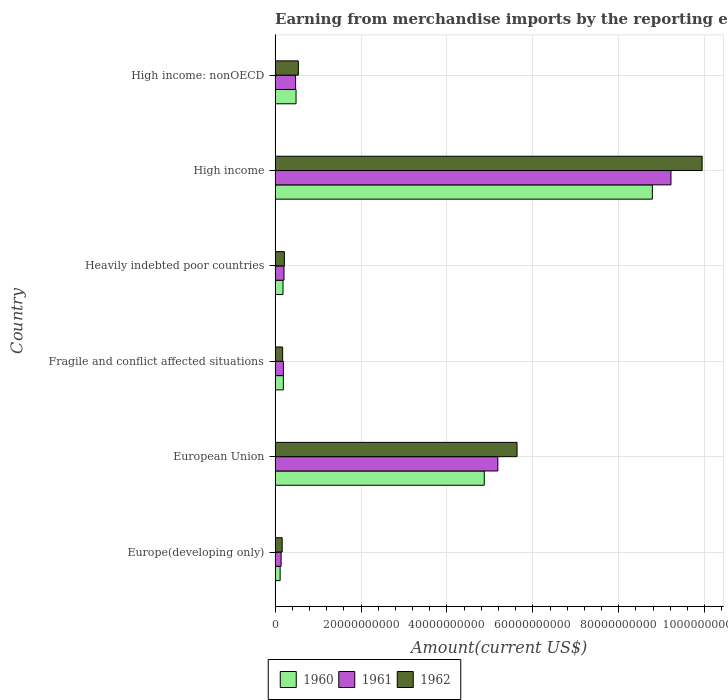How many different coloured bars are there?
Offer a terse response. 3. Are the number of bars on each tick of the Y-axis equal?
Provide a succinct answer. Yes. How many bars are there on the 5th tick from the bottom?
Your response must be concise. 3. What is the amount earned from merchandise imports in 1962 in European Union?
Keep it short and to the point. 5.63e+1. Across all countries, what is the maximum amount earned from merchandise imports in 1962?
Your answer should be compact. 9.94e+1. Across all countries, what is the minimum amount earned from merchandise imports in 1962?
Your answer should be compact. 1.65e+09. In which country was the amount earned from merchandise imports in 1960 maximum?
Provide a short and direct response. High income. In which country was the amount earned from merchandise imports in 1961 minimum?
Provide a short and direct response. Europe(developing only). What is the total amount earned from merchandise imports in 1960 in the graph?
Provide a succinct answer. 1.46e+11. What is the difference between the amount earned from merchandise imports in 1962 in Europe(developing only) and that in Heavily indebted poor countries?
Your response must be concise. -5.09e+08. What is the difference between the amount earned from merchandise imports in 1961 in Heavily indebted poor countries and the amount earned from merchandise imports in 1960 in European Union?
Your response must be concise. -4.66e+1. What is the average amount earned from merchandise imports in 1962 per country?
Ensure brevity in your answer.  2.78e+1. What is the difference between the amount earned from merchandise imports in 1962 and amount earned from merchandise imports in 1961 in High income?
Offer a terse response. 7.26e+09. In how many countries, is the amount earned from merchandise imports in 1962 greater than 76000000000 US$?
Give a very brief answer. 1. What is the ratio of the amount earned from merchandise imports in 1962 in Europe(developing only) to that in High income: nonOECD?
Keep it short and to the point. 0.31. What is the difference between the highest and the second highest amount earned from merchandise imports in 1962?
Ensure brevity in your answer.  4.31e+1. What is the difference between the highest and the lowest amount earned from merchandise imports in 1962?
Your answer should be very brief. 9.78e+1. Is the sum of the amount earned from merchandise imports in 1961 in Europe(developing only) and Fragile and conflict affected situations greater than the maximum amount earned from merchandise imports in 1960 across all countries?
Your answer should be very brief. No. How many countries are there in the graph?
Provide a succinct answer. 6. Are the values on the major ticks of X-axis written in scientific E-notation?
Provide a short and direct response. No. Does the graph contain any zero values?
Your answer should be compact. No. How many legend labels are there?
Keep it short and to the point. 3. What is the title of the graph?
Ensure brevity in your answer.  Earning from merchandise imports by the reporting economy. Does "1993" appear as one of the legend labels in the graph?
Your answer should be compact. No. What is the label or title of the X-axis?
Give a very brief answer. Amount(current US$). What is the label or title of the Y-axis?
Your response must be concise. Country. What is the Amount(current US$) of 1960 in Europe(developing only)?
Your response must be concise. 1.18e+09. What is the Amount(current US$) of 1961 in Europe(developing only)?
Provide a succinct answer. 1.40e+09. What is the Amount(current US$) of 1962 in Europe(developing only)?
Keep it short and to the point. 1.65e+09. What is the Amount(current US$) of 1960 in European Union?
Your response must be concise. 4.87e+1. What is the Amount(current US$) in 1961 in European Union?
Provide a short and direct response. 5.18e+1. What is the Amount(current US$) of 1962 in European Union?
Offer a terse response. 5.63e+1. What is the Amount(current US$) of 1960 in Fragile and conflict affected situations?
Ensure brevity in your answer.  1.92e+09. What is the Amount(current US$) in 1961 in Fragile and conflict affected situations?
Your response must be concise. 1.94e+09. What is the Amount(current US$) in 1962 in Fragile and conflict affected situations?
Your response must be concise. 1.76e+09. What is the Amount(current US$) in 1960 in Heavily indebted poor countries?
Give a very brief answer. 1.84e+09. What is the Amount(current US$) in 1961 in Heavily indebted poor countries?
Keep it short and to the point. 2.07e+09. What is the Amount(current US$) in 1962 in Heavily indebted poor countries?
Your answer should be very brief. 2.16e+09. What is the Amount(current US$) in 1960 in High income?
Provide a short and direct response. 8.78e+1. What is the Amount(current US$) in 1961 in High income?
Your response must be concise. 9.21e+1. What is the Amount(current US$) in 1962 in High income?
Ensure brevity in your answer.  9.94e+1. What is the Amount(current US$) in 1960 in High income: nonOECD?
Provide a short and direct response. 4.88e+09. What is the Amount(current US$) in 1961 in High income: nonOECD?
Give a very brief answer. 4.77e+09. What is the Amount(current US$) of 1962 in High income: nonOECD?
Give a very brief answer. 5.41e+09. Across all countries, what is the maximum Amount(current US$) in 1960?
Your response must be concise. 8.78e+1. Across all countries, what is the maximum Amount(current US$) in 1961?
Make the answer very short. 9.21e+1. Across all countries, what is the maximum Amount(current US$) of 1962?
Your answer should be compact. 9.94e+1. Across all countries, what is the minimum Amount(current US$) in 1960?
Give a very brief answer. 1.18e+09. Across all countries, what is the minimum Amount(current US$) of 1961?
Keep it short and to the point. 1.40e+09. Across all countries, what is the minimum Amount(current US$) in 1962?
Offer a very short reply. 1.65e+09. What is the total Amount(current US$) of 1960 in the graph?
Your answer should be very brief. 1.46e+11. What is the total Amount(current US$) in 1961 in the graph?
Make the answer very short. 1.54e+11. What is the total Amount(current US$) of 1962 in the graph?
Offer a terse response. 1.67e+11. What is the difference between the Amount(current US$) in 1960 in Europe(developing only) and that in European Union?
Provide a short and direct response. -4.75e+1. What is the difference between the Amount(current US$) of 1961 in Europe(developing only) and that in European Union?
Provide a short and direct response. -5.04e+1. What is the difference between the Amount(current US$) of 1962 in Europe(developing only) and that in European Union?
Offer a very short reply. -5.47e+1. What is the difference between the Amount(current US$) of 1960 in Europe(developing only) and that in Fragile and conflict affected situations?
Provide a succinct answer. -7.44e+08. What is the difference between the Amount(current US$) of 1961 in Europe(developing only) and that in Fragile and conflict affected situations?
Your response must be concise. -5.35e+08. What is the difference between the Amount(current US$) in 1962 in Europe(developing only) and that in Fragile and conflict affected situations?
Ensure brevity in your answer.  -1.08e+08. What is the difference between the Amount(current US$) in 1960 in Europe(developing only) and that in Heavily indebted poor countries?
Your answer should be compact. -6.63e+08. What is the difference between the Amount(current US$) of 1961 in Europe(developing only) and that in Heavily indebted poor countries?
Offer a very short reply. -6.70e+08. What is the difference between the Amount(current US$) of 1962 in Europe(developing only) and that in Heavily indebted poor countries?
Provide a short and direct response. -5.09e+08. What is the difference between the Amount(current US$) in 1960 in Europe(developing only) and that in High income?
Give a very brief answer. -8.66e+1. What is the difference between the Amount(current US$) of 1961 in Europe(developing only) and that in High income?
Keep it short and to the point. -9.07e+1. What is the difference between the Amount(current US$) in 1962 in Europe(developing only) and that in High income?
Provide a short and direct response. -9.78e+1. What is the difference between the Amount(current US$) of 1960 in Europe(developing only) and that in High income: nonOECD?
Provide a short and direct response. -3.70e+09. What is the difference between the Amount(current US$) of 1961 in Europe(developing only) and that in High income: nonOECD?
Your answer should be very brief. -3.37e+09. What is the difference between the Amount(current US$) of 1962 in Europe(developing only) and that in High income: nonOECD?
Make the answer very short. -3.76e+09. What is the difference between the Amount(current US$) of 1960 in European Union and that in Fragile and conflict affected situations?
Keep it short and to the point. 4.68e+1. What is the difference between the Amount(current US$) of 1961 in European Union and that in Fragile and conflict affected situations?
Your response must be concise. 4.99e+1. What is the difference between the Amount(current US$) in 1962 in European Union and that in Fragile and conflict affected situations?
Your response must be concise. 5.46e+1. What is the difference between the Amount(current US$) in 1960 in European Union and that in Heavily indebted poor countries?
Your response must be concise. 4.68e+1. What is the difference between the Amount(current US$) of 1961 in European Union and that in Heavily indebted poor countries?
Give a very brief answer. 4.98e+1. What is the difference between the Amount(current US$) of 1962 in European Union and that in Heavily indebted poor countries?
Your response must be concise. 5.42e+1. What is the difference between the Amount(current US$) in 1960 in European Union and that in High income?
Your answer should be compact. -3.91e+1. What is the difference between the Amount(current US$) of 1961 in European Union and that in High income?
Give a very brief answer. -4.03e+1. What is the difference between the Amount(current US$) of 1962 in European Union and that in High income?
Offer a terse response. -4.31e+1. What is the difference between the Amount(current US$) of 1960 in European Union and that in High income: nonOECD?
Your answer should be compact. 4.38e+1. What is the difference between the Amount(current US$) of 1961 in European Union and that in High income: nonOECD?
Provide a short and direct response. 4.71e+1. What is the difference between the Amount(current US$) of 1962 in European Union and that in High income: nonOECD?
Your response must be concise. 5.09e+1. What is the difference between the Amount(current US$) in 1960 in Fragile and conflict affected situations and that in Heavily indebted poor countries?
Offer a very short reply. 8.08e+07. What is the difference between the Amount(current US$) of 1961 in Fragile and conflict affected situations and that in Heavily indebted poor countries?
Your answer should be very brief. -1.34e+08. What is the difference between the Amount(current US$) in 1962 in Fragile and conflict affected situations and that in Heavily indebted poor countries?
Provide a short and direct response. -4.01e+08. What is the difference between the Amount(current US$) of 1960 in Fragile and conflict affected situations and that in High income?
Your answer should be compact. -8.59e+1. What is the difference between the Amount(current US$) of 1961 in Fragile and conflict affected situations and that in High income?
Your answer should be very brief. -9.02e+1. What is the difference between the Amount(current US$) in 1962 in Fragile and conflict affected situations and that in High income?
Your answer should be compact. -9.76e+1. What is the difference between the Amount(current US$) of 1960 in Fragile and conflict affected situations and that in High income: nonOECD?
Give a very brief answer. -2.96e+09. What is the difference between the Amount(current US$) of 1961 in Fragile and conflict affected situations and that in High income: nonOECD?
Your answer should be compact. -2.83e+09. What is the difference between the Amount(current US$) of 1962 in Fragile and conflict affected situations and that in High income: nonOECD?
Make the answer very short. -3.65e+09. What is the difference between the Amount(current US$) in 1960 in Heavily indebted poor countries and that in High income?
Your answer should be very brief. -8.60e+1. What is the difference between the Amount(current US$) in 1961 in Heavily indebted poor countries and that in High income?
Provide a succinct answer. -9.01e+1. What is the difference between the Amount(current US$) of 1962 in Heavily indebted poor countries and that in High income?
Give a very brief answer. -9.72e+1. What is the difference between the Amount(current US$) in 1960 in Heavily indebted poor countries and that in High income: nonOECD?
Ensure brevity in your answer.  -3.04e+09. What is the difference between the Amount(current US$) of 1961 in Heavily indebted poor countries and that in High income: nonOECD?
Your answer should be compact. -2.70e+09. What is the difference between the Amount(current US$) of 1962 in Heavily indebted poor countries and that in High income: nonOECD?
Keep it short and to the point. -3.25e+09. What is the difference between the Amount(current US$) in 1960 in High income and that in High income: nonOECD?
Provide a short and direct response. 8.29e+1. What is the difference between the Amount(current US$) in 1961 in High income and that in High income: nonOECD?
Provide a succinct answer. 8.74e+1. What is the difference between the Amount(current US$) of 1962 in High income and that in High income: nonOECD?
Make the answer very short. 9.40e+1. What is the difference between the Amount(current US$) of 1960 in Europe(developing only) and the Amount(current US$) of 1961 in European Union?
Offer a very short reply. -5.07e+1. What is the difference between the Amount(current US$) of 1960 in Europe(developing only) and the Amount(current US$) of 1962 in European Union?
Provide a short and direct response. -5.51e+1. What is the difference between the Amount(current US$) of 1961 in Europe(developing only) and the Amount(current US$) of 1962 in European Union?
Your answer should be compact. -5.49e+1. What is the difference between the Amount(current US$) of 1960 in Europe(developing only) and the Amount(current US$) of 1961 in Fragile and conflict affected situations?
Keep it short and to the point. -7.59e+08. What is the difference between the Amount(current US$) in 1960 in Europe(developing only) and the Amount(current US$) in 1962 in Fragile and conflict affected situations?
Provide a short and direct response. -5.81e+08. What is the difference between the Amount(current US$) in 1961 in Europe(developing only) and the Amount(current US$) in 1962 in Fragile and conflict affected situations?
Offer a very short reply. -3.57e+08. What is the difference between the Amount(current US$) in 1960 in Europe(developing only) and the Amount(current US$) in 1961 in Heavily indebted poor countries?
Offer a terse response. -8.93e+08. What is the difference between the Amount(current US$) of 1960 in Europe(developing only) and the Amount(current US$) of 1962 in Heavily indebted poor countries?
Offer a very short reply. -9.82e+08. What is the difference between the Amount(current US$) in 1961 in Europe(developing only) and the Amount(current US$) in 1962 in Heavily indebted poor countries?
Your answer should be very brief. -7.58e+08. What is the difference between the Amount(current US$) in 1960 in Europe(developing only) and the Amount(current US$) in 1961 in High income?
Your response must be concise. -9.10e+1. What is the difference between the Amount(current US$) of 1960 in Europe(developing only) and the Amount(current US$) of 1962 in High income?
Give a very brief answer. -9.82e+1. What is the difference between the Amount(current US$) in 1961 in Europe(developing only) and the Amount(current US$) in 1962 in High income?
Your answer should be compact. -9.80e+1. What is the difference between the Amount(current US$) of 1960 in Europe(developing only) and the Amount(current US$) of 1961 in High income: nonOECD?
Your answer should be very brief. -3.59e+09. What is the difference between the Amount(current US$) of 1960 in Europe(developing only) and the Amount(current US$) of 1962 in High income: nonOECD?
Your answer should be compact. -4.24e+09. What is the difference between the Amount(current US$) in 1961 in Europe(developing only) and the Amount(current US$) in 1962 in High income: nonOECD?
Your response must be concise. -4.01e+09. What is the difference between the Amount(current US$) of 1960 in European Union and the Amount(current US$) of 1961 in Fragile and conflict affected situations?
Give a very brief answer. 4.68e+1. What is the difference between the Amount(current US$) of 1960 in European Union and the Amount(current US$) of 1962 in Fragile and conflict affected situations?
Your answer should be very brief. 4.69e+1. What is the difference between the Amount(current US$) in 1961 in European Union and the Amount(current US$) in 1962 in Fragile and conflict affected situations?
Provide a succinct answer. 5.01e+1. What is the difference between the Amount(current US$) in 1960 in European Union and the Amount(current US$) in 1961 in Heavily indebted poor countries?
Ensure brevity in your answer.  4.66e+1. What is the difference between the Amount(current US$) in 1960 in European Union and the Amount(current US$) in 1962 in Heavily indebted poor countries?
Your answer should be very brief. 4.65e+1. What is the difference between the Amount(current US$) in 1961 in European Union and the Amount(current US$) in 1962 in Heavily indebted poor countries?
Make the answer very short. 4.97e+1. What is the difference between the Amount(current US$) of 1960 in European Union and the Amount(current US$) of 1961 in High income?
Your response must be concise. -4.35e+1. What is the difference between the Amount(current US$) in 1960 in European Union and the Amount(current US$) in 1962 in High income?
Make the answer very short. -5.07e+1. What is the difference between the Amount(current US$) of 1961 in European Union and the Amount(current US$) of 1962 in High income?
Offer a terse response. -4.76e+1. What is the difference between the Amount(current US$) of 1960 in European Union and the Amount(current US$) of 1961 in High income: nonOECD?
Offer a very short reply. 4.39e+1. What is the difference between the Amount(current US$) of 1960 in European Union and the Amount(current US$) of 1962 in High income: nonOECD?
Offer a terse response. 4.33e+1. What is the difference between the Amount(current US$) of 1961 in European Union and the Amount(current US$) of 1962 in High income: nonOECD?
Provide a short and direct response. 4.64e+1. What is the difference between the Amount(current US$) in 1960 in Fragile and conflict affected situations and the Amount(current US$) in 1961 in Heavily indebted poor countries?
Your response must be concise. -1.49e+08. What is the difference between the Amount(current US$) in 1960 in Fragile and conflict affected situations and the Amount(current US$) in 1962 in Heavily indebted poor countries?
Provide a succinct answer. -2.38e+08. What is the difference between the Amount(current US$) in 1961 in Fragile and conflict affected situations and the Amount(current US$) in 1962 in Heavily indebted poor countries?
Give a very brief answer. -2.23e+08. What is the difference between the Amount(current US$) in 1960 in Fragile and conflict affected situations and the Amount(current US$) in 1961 in High income?
Offer a terse response. -9.02e+1. What is the difference between the Amount(current US$) in 1960 in Fragile and conflict affected situations and the Amount(current US$) in 1962 in High income?
Give a very brief answer. -9.75e+1. What is the difference between the Amount(current US$) of 1961 in Fragile and conflict affected situations and the Amount(current US$) of 1962 in High income?
Provide a succinct answer. -9.75e+1. What is the difference between the Amount(current US$) in 1960 in Fragile and conflict affected situations and the Amount(current US$) in 1961 in High income: nonOECD?
Offer a terse response. -2.85e+09. What is the difference between the Amount(current US$) in 1960 in Fragile and conflict affected situations and the Amount(current US$) in 1962 in High income: nonOECD?
Your answer should be compact. -3.49e+09. What is the difference between the Amount(current US$) in 1961 in Fragile and conflict affected situations and the Amount(current US$) in 1962 in High income: nonOECD?
Keep it short and to the point. -3.48e+09. What is the difference between the Amount(current US$) in 1960 in Heavily indebted poor countries and the Amount(current US$) in 1961 in High income?
Keep it short and to the point. -9.03e+1. What is the difference between the Amount(current US$) in 1960 in Heavily indebted poor countries and the Amount(current US$) in 1962 in High income?
Provide a short and direct response. -9.76e+1. What is the difference between the Amount(current US$) of 1961 in Heavily indebted poor countries and the Amount(current US$) of 1962 in High income?
Keep it short and to the point. -9.73e+1. What is the difference between the Amount(current US$) of 1960 in Heavily indebted poor countries and the Amount(current US$) of 1961 in High income: nonOECD?
Make the answer very short. -2.93e+09. What is the difference between the Amount(current US$) of 1960 in Heavily indebted poor countries and the Amount(current US$) of 1962 in High income: nonOECD?
Provide a short and direct response. -3.57e+09. What is the difference between the Amount(current US$) of 1961 in Heavily indebted poor countries and the Amount(current US$) of 1962 in High income: nonOECD?
Provide a short and direct response. -3.34e+09. What is the difference between the Amount(current US$) in 1960 in High income and the Amount(current US$) in 1961 in High income: nonOECD?
Keep it short and to the point. 8.30e+1. What is the difference between the Amount(current US$) in 1960 in High income and the Amount(current US$) in 1962 in High income: nonOECD?
Your answer should be compact. 8.24e+1. What is the difference between the Amount(current US$) of 1961 in High income and the Amount(current US$) of 1962 in High income: nonOECD?
Provide a short and direct response. 8.67e+1. What is the average Amount(current US$) in 1960 per country?
Make the answer very short. 2.44e+1. What is the average Amount(current US$) in 1961 per country?
Your response must be concise. 2.57e+1. What is the average Amount(current US$) of 1962 per country?
Your answer should be compact. 2.78e+1. What is the difference between the Amount(current US$) in 1960 and Amount(current US$) in 1961 in Europe(developing only)?
Make the answer very short. -2.23e+08. What is the difference between the Amount(current US$) of 1960 and Amount(current US$) of 1962 in Europe(developing only)?
Provide a succinct answer. -4.73e+08. What is the difference between the Amount(current US$) in 1961 and Amount(current US$) in 1962 in Europe(developing only)?
Ensure brevity in your answer.  -2.50e+08. What is the difference between the Amount(current US$) in 1960 and Amount(current US$) in 1961 in European Union?
Provide a short and direct response. -3.16e+09. What is the difference between the Amount(current US$) in 1960 and Amount(current US$) in 1962 in European Union?
Your answer should be compact. -7.63e+09. What is the difference between the Amount(current US$) in 1961 and Amount(current US$) in 1962 in European Union?
Provide a short and direct response. -4.47e+09. What is the difference between the Amount(current US$) of 1960 and Amount(current US$) of 1961 in Fragile and conflict affected situations?
Ensure brevity in your answer.  -1.49e+07. What is the difference between the Amount(current US$) in 1960 and Amount(current US$) in 1962 in Fragile and conflict affected situations?
Offer a terse response. 1.63e+08. What is the difference between the Amount(current US$) of 1961 and Amount(current US$) of 1962 in Fragile and conflict affected situations?
Your answer should be compact. 1.78e+08. What is the difference between the Amount(current US$) in 1960 and Amount(current US$) in 1961 in Heavily indebted poor countries?
Make the answer very short. -2.30e+08. What is the difference between the Amount(current US$) in 1960 and Amount(current US$) in 1962 in Heavily indebted poor countries?
Provide a short and direct response. -3.19e+08. What is the difference between the Amount(current US$) of 1961 and Amount(current US$) of 1962 in Heavily indebted poor countries?
Provide a short and direct response. -8.88e+07. What is the difference between the Amount(current US$) of 1960 and Amount(current US$) of 1961 in High income?
Give a very brief answer. -4.34e+09. What is the difference between the Amount(current US$) of 1960 and Amount(current US$) of 1962 in High income?
Offer a terse response. -1.16e+1. What is the difference between the Amount(current US$) of 1961 and Amount(current US$) of 1962 in High income?
Provide a succinct answer. -7.26e+09. What is the difference between the Amount(current US$) in 1960 and Amount(current US$) in 1961 in High income: nonOECD?
Provide a succinct answer. 1.11e+08. What is the difference between the Amount(current US$) in 1960 and Amount(current US$) in 1962 in High income: nonOECD?
Give a very brief answer. -5.33e+08. What is the difference between the Amount(current US$) in 1961 and Amount(current US$) in 1962 in High income: nonOECD?
Keep it short and to the point. -6.43e+08. What is the ratio of the Amount(current US$) in 1960 in Europe(developing only) to that in European Union?
Keep it short and to the point. 0.02. What is the ratio of the Amount(current US$) of 1961 in Europe(developing only) to that in European Union?
Your answer should be very brief. 0.03. What is the ratio of the Amount(current US$) of 1962 in Europe(developing only) to that in European Union?
Make the answer very short. 0.03. What is the ratio of the Amount(current US$) in 1960 in Europe(developing only) to that in Fragile and conflict affected situations?
Ensure brevity in your answer.  0.61. What is the ratio of the Amount(current US$) in 1961 in Europe(developing only) to that in Fragile and conflict affected situations?
Make the answer very short. 0.72. What is the ratio of the Amount(current US$) of 1962 in Europe(developing only) to that in Fragile and conflict affected situations?
Give a very brief answer. 0.94. What is the ratio of the Amount(current US$) in 1960 in Europe(developing only) to that in Heavily indebted poor countries?
Make the answer very short. 0.64. What is the ratio of the Amount(current US$) in 1961 in Europe(developing only) to that in Heavily indebted poor countries?
Provide a short and direct response. 0.68. What is the ratio of the Amount(current US$) of 1962 in Europe(developing only) to that in Heavily indebted poor countries?
Make the answer very short. 0.76. What is the ratio of the Amount(current US$) of 1960 in Europe(developing only) to that in High income?
Provide a succinct answer. 0.01. What is the ratio of the Amount(current US$) of 1961 in Europe(developing only) to that in High income?
Make the answer very short. 0.02. What is the ratio of the Amount(current US$) of 1962 in Europe(developing only) to that in High income?
Provide a succinct answer. 0.02. What is the ratio of the Amount(current US$) in 1960 in Europe(developing only) to that in High income: nonOECD?
Give a very brief answer. 0.24. What is the ratio of the Amount(current US$) in 1961 in Europe(developing only) to that in High income: nonOECD?
Your response must be concise. 0.29. What is the ratio of the Amount(current US$) of 1962 in Europe(developing only) to that in High income: nonOECD?
Provide a succinct answer. 0.31. What is the ratio of the Amount(current US$) in 1960 in European Union to that in Fragile and conflict affected situations?
Make the answer very short. 25.32. What is the ratio of the Amount(current US$) of 1961 in European Union to that in Fragile and conflict affected situations?
Your answer should be very brief. 26.76. What is the ratio of the Amount(current US$) in 1962 in European Union to that in Fragile and conflict affected situations?
Ensure brevity in your answer.  32. What is the ratio of the Amount(current US$) in 1960 in European Union to that in Heavily indebted poor countries?
Ensure brevity in your answer.  26.43. What is the ratio of the Amount(current US$) in 1961 in European Union to that in Heavily indebted poor countries?
Keep it short and to the point. 25.02. What is the ratio of the Amount(current US$) of 1962 in European Union to that in Heavily indebted poor countries?
Provide a short and direct response. 26.06. What is the ratio of the Amount(current US$) in 1960 in European Union to that in High income?
Provide a short and direct response. 0.55. What is the ratio of the Amount(current US$) in 1961 in European Union to that in High income?
Make the answer very short. 0.56. What is the ratio of the Amount(current US$) in 1962 in European Union to that in High income?
Provide a short and direct response. 0.57. What is the ratio of the Amount(current US$) of 1960 in European Union to that in High income: nonOECD?
Offer a terse response. 9.97. What is the ratio of the Amount(current US$) of 1961 in European Union to that in High income: nonOECD?
Make the answer very short. 10.87. What is the ratio of the Amount(current US$) in 1962 in European Union to that in High income: nonOECD?
Your answer should be compact. 10.4. What is the ratio of the Amount(current US$) in 1960 in Fragile and conflict affected situations to that in Heavily indebted poor countries?
Your answer should be very brief. 1.04. What is the ratio of the Amount(current US$) in 1961 in Fragile and conflict affected situations to that in Heavily indebted poor countries?
Give a very brief answer. 0.94. What is the ratio of the Amount(current US$) in 1962 in Fragile and conflict affected situations to that in Heavily indebted poor countries?
Ensure brevity in your answer.  0.81. What is the ratio of the Amount(current US$) of 1960 in Fragile and conflict affected situations to that in High income?
Ensure brevity in your answer.  0.02. What is the ratio of the Amount(current US$) of 1961 in Fragile and conflict affected situations to that in High income?
Ensure brevity in your answer.  0.02. What is the ratio of the Amount(current US$) of 1962 in Fragile and conflict affected situations to that in High income?
Keep it short and to the point. 0.02. What is the ratio of the Amount(current US$) in 1960 in Fragile and conflict affected situations to that in High income: nonOECD?
Ensure brevity in your answer.  0.39. What is the ratio of the Amount(current US$) in 1961 in Fragile and conflict affected situations to that in High income: nonOECD?
Provide a short and direct response. 0.41. What is the ratio of the Amount(current US$) in 1962 in Fragile and conflict affected situations to that in High income: nonOECD?
Offer a terse response. 0.33. What is the ratio of the Amount(current US$) in 1960 in Heavily indebted poor countries to that in High income?
Keep it short and to the point. 0.02. What is the ratio of the Amount(current US$) in 1961 in Heavily indebted poor countries to that in High income?
Provide a succinct answer. 0.02. What is the ratio of the Amount(current US$) in 1962 in Heavily indebted poor countries to that in High income?
Ensure brevity in your answer.  0.02. What is the ratio of the Amount(current US$) in 1960 in Heavily indebted poor countries to that in High income: nonOECD?
Offer a terse response. 0.38. What is the ratio of the Amount(current US$) in 1961 in Heavily indebted poor countries to that in High income: nonOECD?
Your answer should be compact. 0.43. What is the ratio of the Amount(current US$) in 1962 in Heavily indebted poor countries to that in High income: nonOECD?
Make the answer very short. 0.4. What is the ratio of the Amount(current US$) in 1960 in High income to that in High income: nonOECD?
Your answer should be very brief. 17.99. What is the ratio of the Amount(current US$) in 1961 in High income to that in High income: nonOECD?
Your answer should be compact. 19.31. What is the ratio of the Amount(current US$) of 1962 in High income to that in High income: nonOECD?
Offer a very short reply. 18.36. What is the difference between the highest and the second highest Amount(current US$) of 1960?
Your answer should be very brief. 3.91e+1. What is the difference between the highest and the second highest Amount(current US$) of 1961?
Ensure brevity in your answer.  4.03e+1. What is the difference between the highest and the second highest Amount(current US$) in 1962?
Make the answer very short. 4.31e+1. What is the difference between the highest and the lowest Amount(current US$) of 1960?
Provide a succinct answer. 8.66e+1. What is the difference between the highest and the lowest Amount(current US$) in 1961?
Give a very brief answer. 9.07e+1. What is the difference between the highest and the lowest Amount(current US$) of 1962?
Your response must be concise. 9.78e+1. 